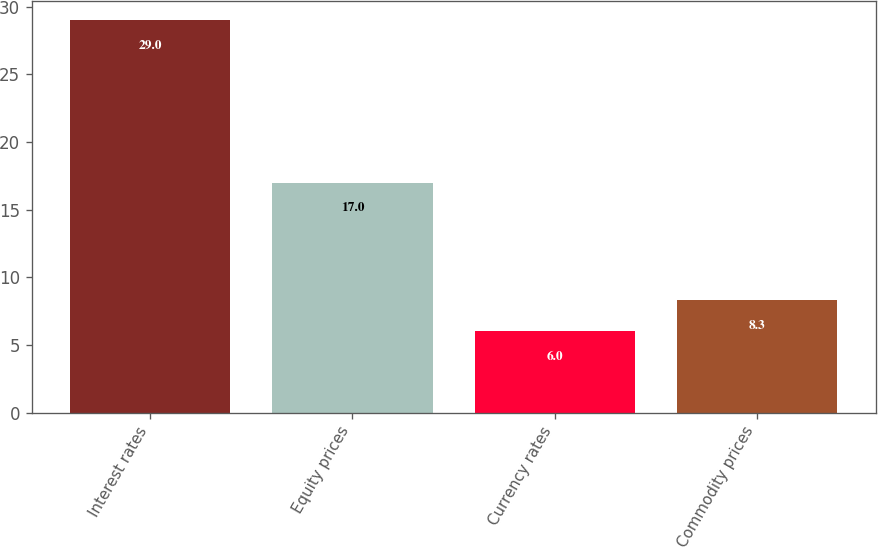Convert chart. <chart><loc_0><loc_0><loc_500><loc_500><bar_chart><fcel>Interest rates<fcel>Equity prices<fcel>Currency rates<fcel>Commodity prices<nl><fcel>29<fcel>17<fcel>6<fcel>8.3<nl></chart> 